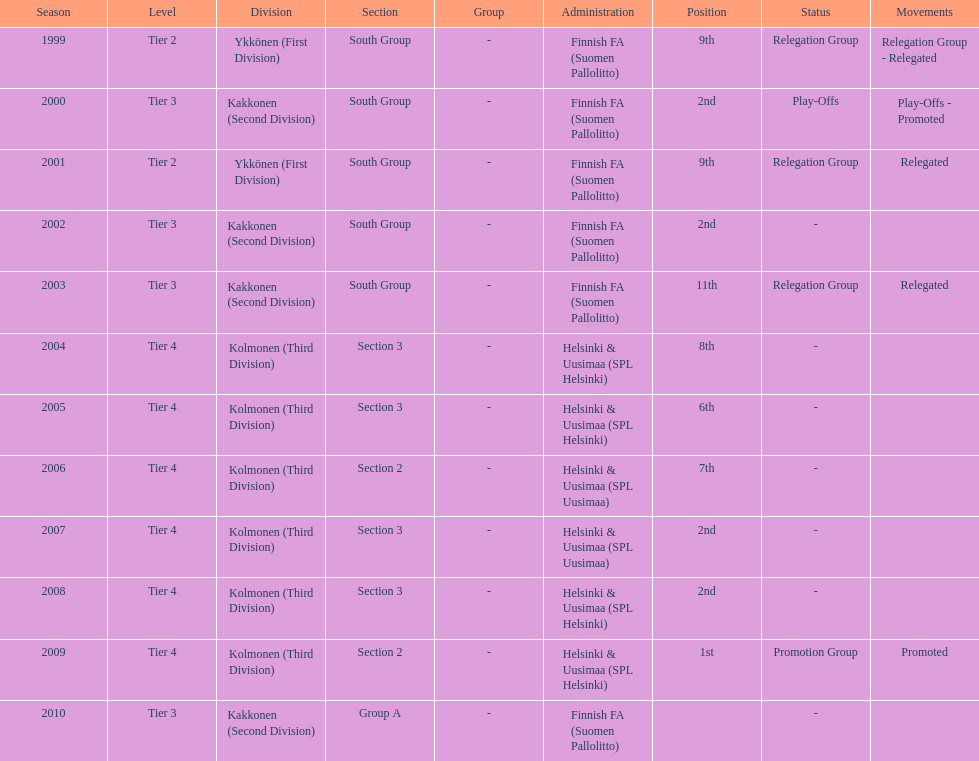What is the first tier listed? Tier 2. 